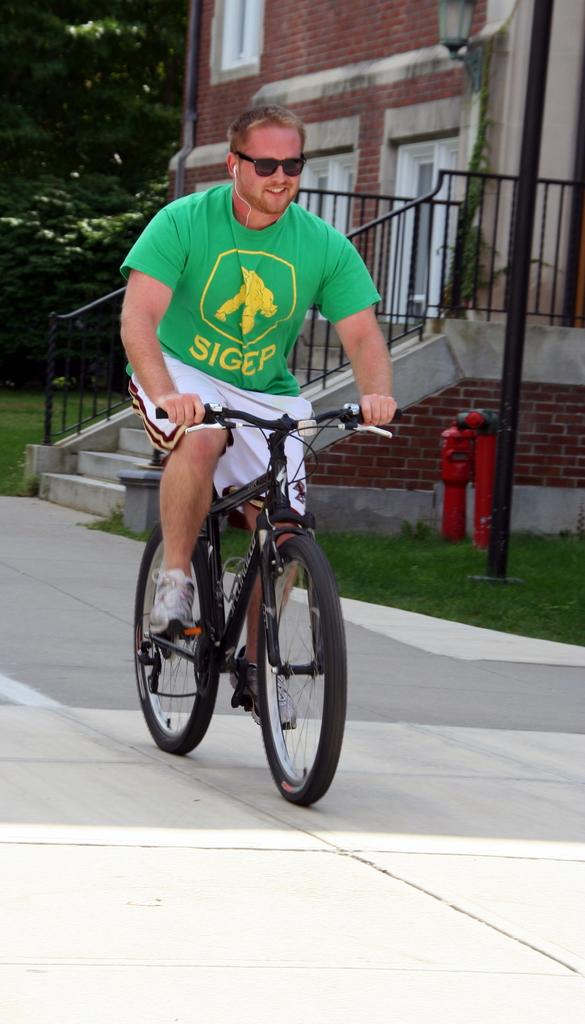What is the man in the image doing? The man is riding a bicycle in the image. What can be seen in the background of the image? There is a house, a pole, and a tree in the background of the image. What type of liquid is the man using to ride the bicycle in the image? There is no liquid mentioned or visible in the image; the man is riding a bicycle on a solid surface. 